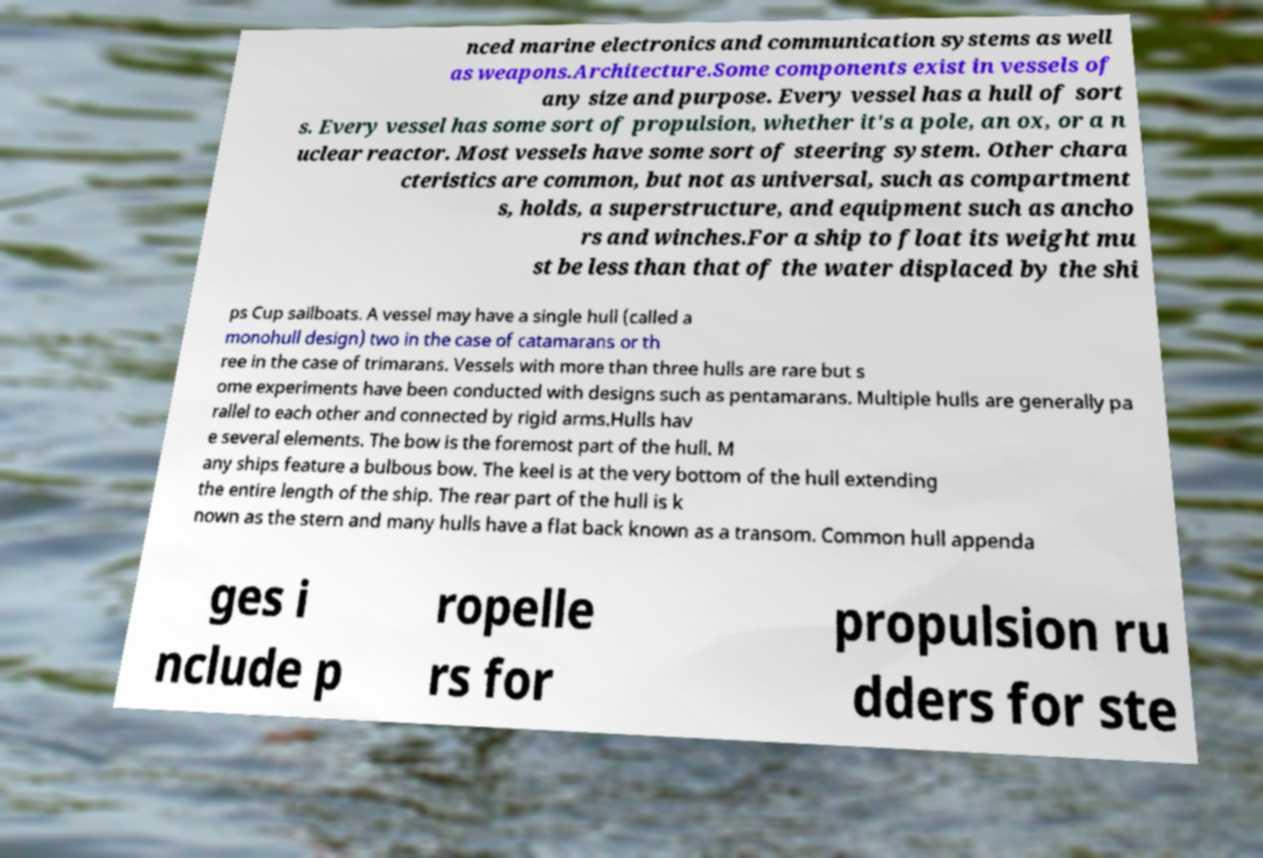Please read and relay the text visible in this image. What does it say? nced marine electronics and communication systems as well as weapons.Architecture.Some components exist in vessels of any size and purpose. Every vessel has a hull of sort s. Every vessel has some sort of propulsion, whether it's a pole, an ox, or a n uclear reactor. Most vessels have some sort of steering system. Other chara cteristics are common, but not as universal, such as compartment s, holds, a superstructure, and equipment such as ancho rs and winches.For a ship to float its weight mu st be less than that of the water displaced by the shi ps Cup sailboats. A vessel may have a single hull (called a monohull design) two in the case of catamarans or th ree in the case of trimarans. Vessels with more than three hulls are rare but s ome experiments have been conducted with designs such as pentamarans. Multiple hulls are generally pa rallel to each other and connected by rigid arms.Hulls hav e several elements. The bow is the foremost part of the hull. M any ships feature a bulbous bow. The keel is at the very bottom of the hull extending the entire length of the ship. The rear part of the hull is k nown as the stern and many hulls have a flat back known as a transom. Common hull appenda ges i nclude p ropelle rs for propulsion ru dders for ste 